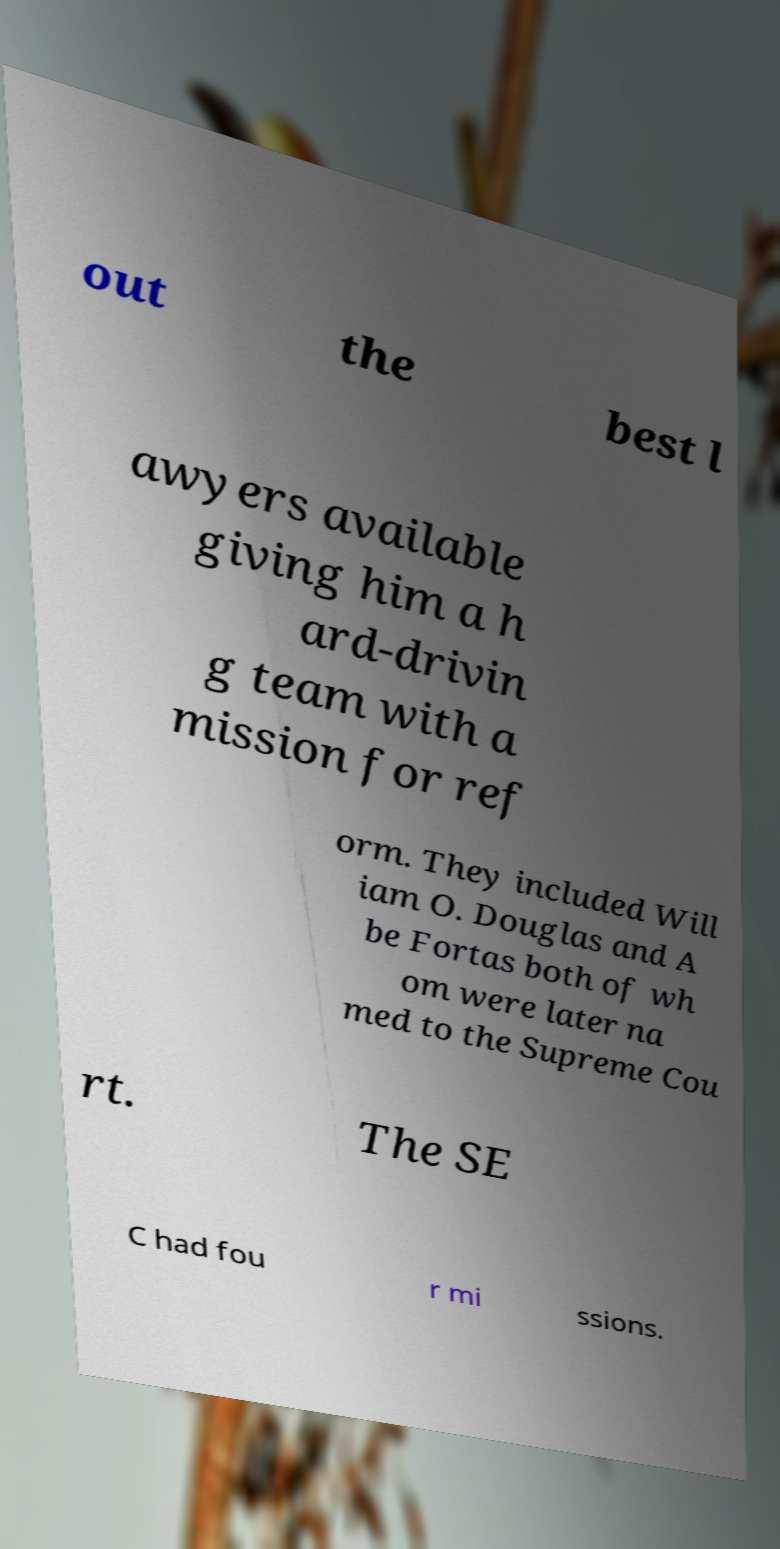Please identify and transcribe the text found in this image. out the best l awyers available giving him a h ard-drivin g team with a mission for ref orm. They included Will iam O. Douglas and A be Fortas both of wh om were later na med to the Supreme Cou rt. The SE C had fou r mi ssions. 